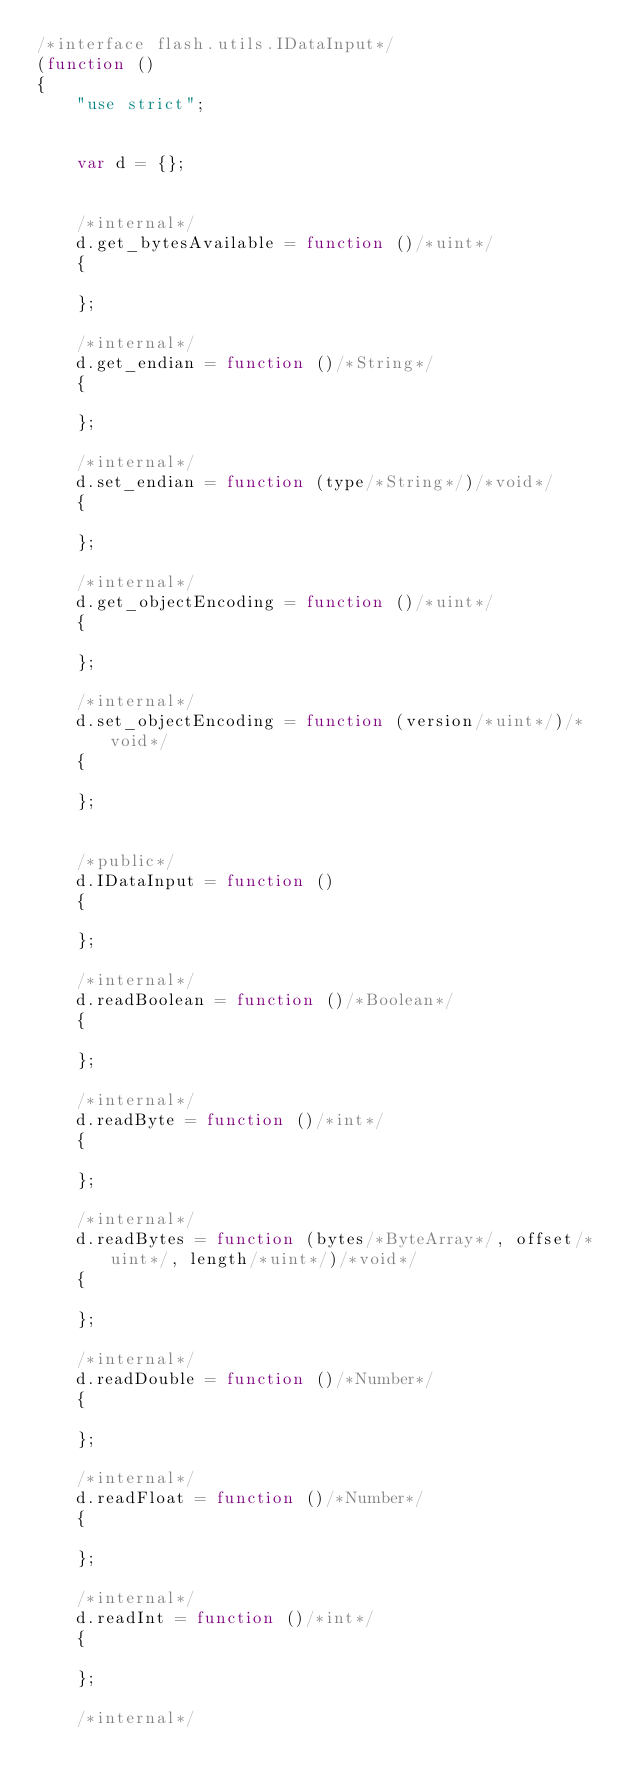Convert code to text. <code><loc_0><loc_0><loc_500><loc_500><_JavaScript_>/*interface flash.utils.IDataInput*/
(function ()
{
	"use strict";
	
	
	var d = {};
	
	
	/*internal*/
	d.get_bytesAvailable = function ()/*uint*/
	{
		
	};
	
	/*internal*/
	d.get_endian = function ()/*String*/
	{
		
	};
	
	/*internal*/
	d.set_endian = function (type/*String*/)/*void*/
	{
		
	};
	
	/*internal*/
	d.get_objectEncoding = function ()/*uint*/
	{
		
	};
	
	/*internal*/
	d.set_objectEncoding = function (version/*uint*/)/*void*/
	{
		
	};
	
	
	/*public*/
	d.IDataInput = function ()
	{
		
	};
	
	/*internal*/
	d.readBoolean = function ()/*Boolean*/
	{
		
	};
	
	/*internal*/
	d.readByte = function ()/*int*/
	{
		
	};
	
	/*internal*/
	d.readBytes = function (bytes/*ByteArray*/, offset/*uint*/, length/*uint*/)/*void*/
	{
		
	};
	
	/*internal*/
	d.readDouble = function ()/*Number*/
	{
		
	};
	
	/*internal*/
	d.readFloat = function ()/*Number*/
	{
		
	};
	
	/*internal*/
	d.readInt = function ()/*int*/
	{
		
	};
	
	/*internal*/</code> 